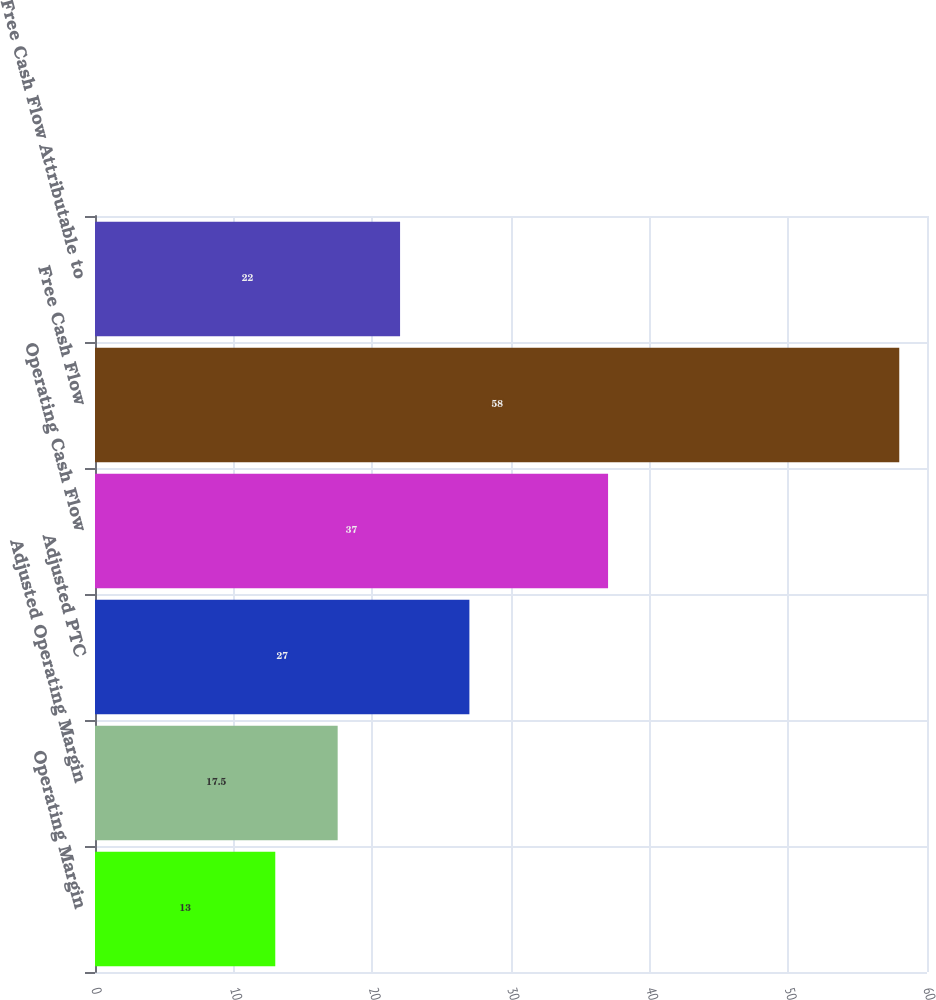Convert chart to OTSL. <chart><loc_0><loc_0><loc_500><loc_500><bar_chart><fcel>Operating Margin<fcel>Adjusted Operating Margin<fcel>Adjusted PTC<fcel>Operating Cash Flow<fcel>Free Cash Flow<fcel>Free Cash Flow Attributable to<nl><fcel>13<fcel>17.5<fcel>27<fcel>37<fcel>58<fcel>22<nl></chart> 